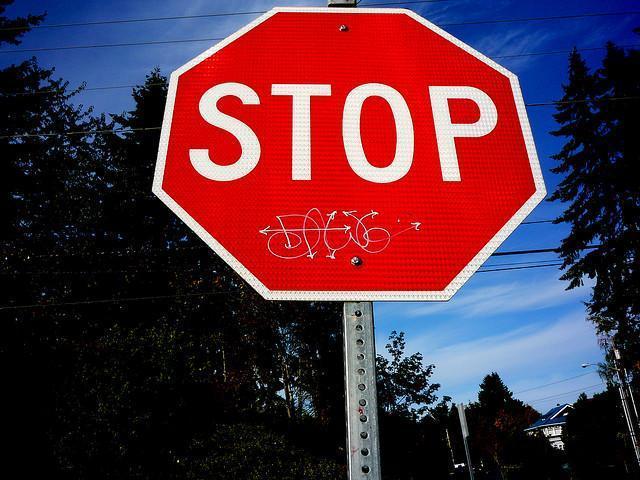How many men are in the picture?
Give a very brief answer. 0. 